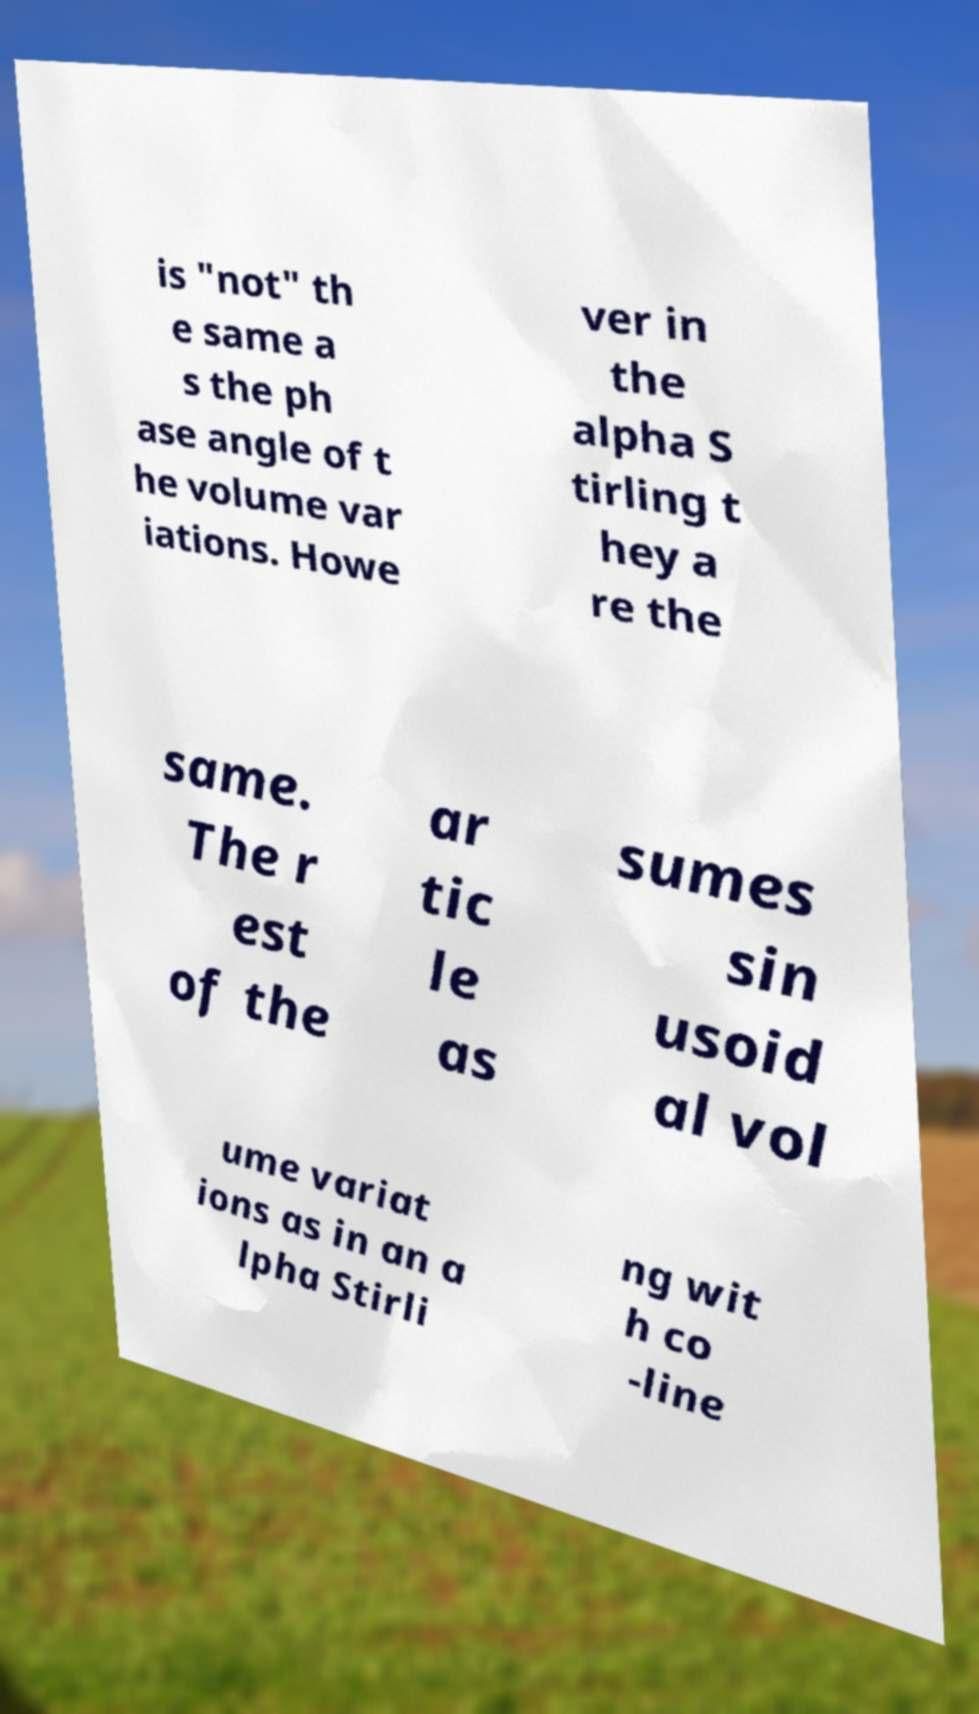What messages or text are displayed in this image? I need them in a readable, typed format. is "not" th e same a s the ph ase angle of t he volume var iations. Howe ver in the alpha S tirling t hey a re the same. The r est of the ar tic le as sumes sin usoid al vol ume variat ions as in an a lpha Stirli ng wit h co -line 